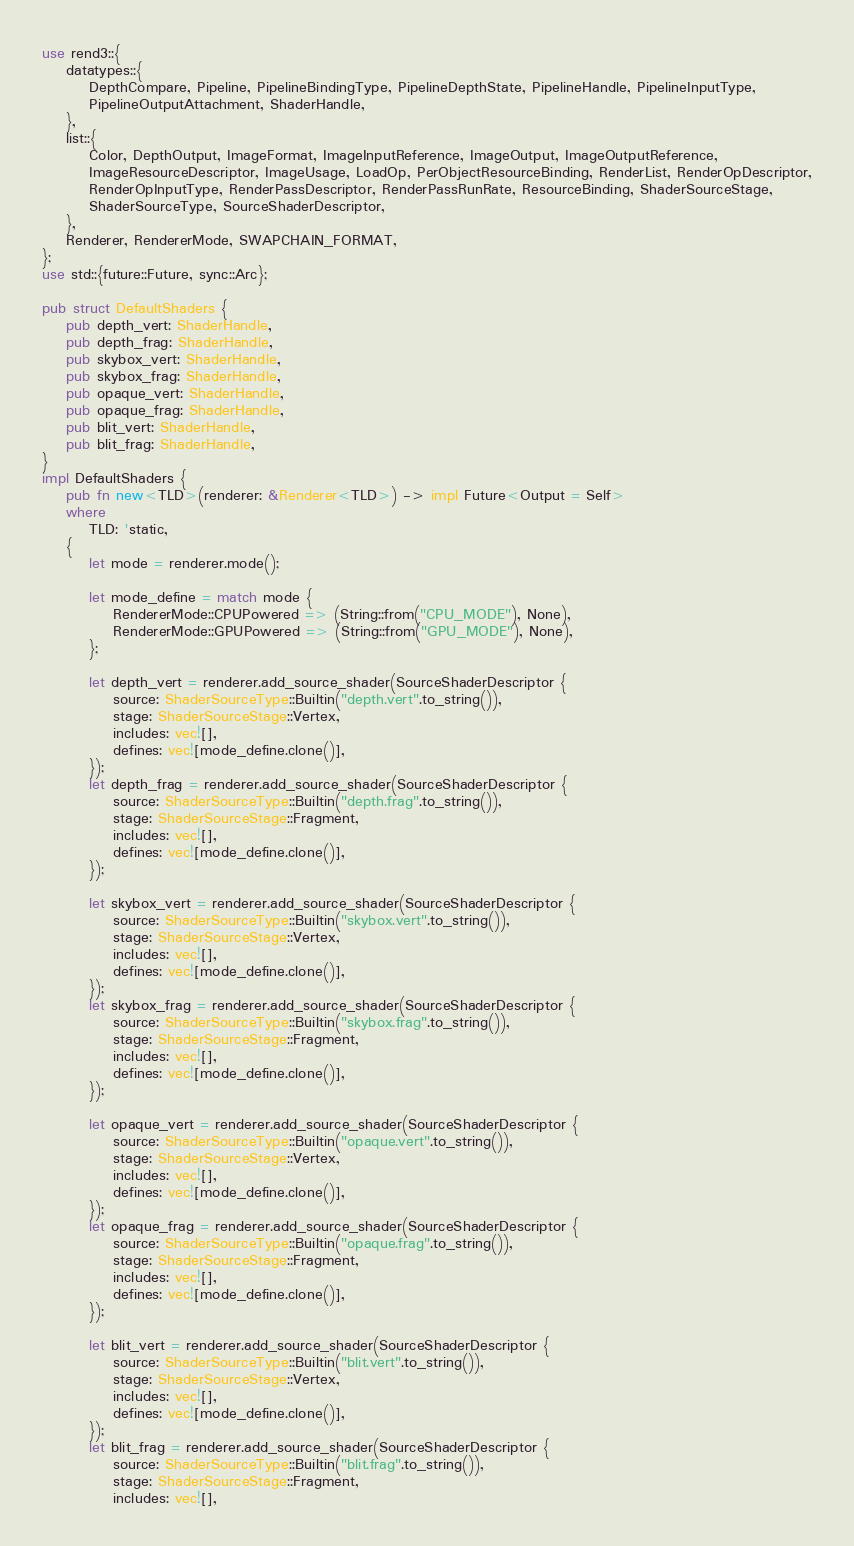<code> <loc_0><loc_0><loc_500><loc_500><_Rust_>use rend3::{
    datatypes::{
        DepthCompare, Pipeline, PipelineBindingType, PipelineDepthState, PipelineHandle, PipelineInputType,
        PipelineOutputAttachment, ShaderHandle,
    },
    list::{
        Color, DepthOutput, ImageFormat, ImageInputReference, ImageOutput, ImageOutputReference,
        ImageResourceDescriptor, ImageUsage, LoadOp, PerObjectResourceBinding, RenderList, RenderOpDescriptor,
        RenderOpInputType, RenderPassDescriptor, RenderPassRunRate, ResourceBinding, ShaderSourceStage,
        ShaderSourceType, SourceShaderDescriptor,
    },
    Renderer, RendererMode, SWAPCHAIN_FORMAT,
};
use std::{future::Future, sync::Arc};

pub struct DefaultShaders {
    pub depth_vert: ShaderHandle,
    pub depth_frag: ShaderHandle,
    pub skybox_vert: ShaderHandle,
    pub skybox_frag: ShaderHandle,
    pub opaque_vert: ShaderHandle,
    pub opaque_frag: ShaderHandle,
    pub blit_vert: ShaderHandle,
    pub blit_frag: ShaderHandle,
}
impl DefaultShaders {
    pub fn new<TLD>(renderer: &Renderer<TLD>) -> impl Future<Output = Self>
    where
        TLD: 'static,
    {
        let mode = renderer.mode();

        let mode_define = match mode {
            RendererMode::CPUPowered => (String::from("CPU_MODE"), None),
            RendererMode::GPUPowered => (String::from("GPU_MODE"), None),
        };

        let depth_vert = renderer.add_source_shader(SourceShaderDescriptor {
            source: ShaderSourceType::Builtin("depth.vert".to_string()),
            stage: ShaderSourceStage::Vertex,
            includes: vec![],
            defines: vec![mode_define.clone()],
        });
        let depth_frag = renderer.add_source_shader(SourceShaderDescriptor {
            source: ShaderSourceType::Builtin("depth.frag".to_string()),
            stage: ShaderSourceStage::Fragment,
            includes: vec![],
            defines: vec![mode_define.clone()],
        });

        let skybox_vert = renderer.add_source_shader(SourceShaderDescriptor {
            source: ShaderSourceType::Builtin("skybox.vert".to_string()),
            stage: ShaderSourceStage::Vertex,
            includes: vec![],
            defines: vec![mode_define.clone()],
        });
        let skybox_frag = renderer.add_source_shader(SourceShaderDescriptor {
            source: ShaderSourceType::Builtin("skybox.frag".to_string()),
            stage: ShaderSourceStage::Fragment,
            includes: vec![],
            defines: vec![mode_define.clone()],
        });

        let opaque_vert = renderer.add_source_shader(SourceShaderDescriptor {
            source: ShaderSourceType::Builtin("opaque.vert".to_string()),
            stage: ShaderSourceStage::Vertex,
            includes: vec![],
            defines: vec![mode_define.clone()],
        });
        let opaque_frag = renderer.add_source_shader(SourceShaderDescriptor {
            source: ShaderSourceType::Builtin("opaque.frag".to_string()),
            stage: ShaderSourceStage::Fragment,
            includes: vec![],
            defines: vec![mode_define.clone()],
        });

        let blit_vert = renderer.add_source_shader(SourceShaderDescriptor {
            source: ShaderSourceType::Builtin("blit.vert".to_string()),
            stage: ShaderSourceStage::Vertex,
            includes: vec![],
            defines: vec![mode_define.clone()],
        });
        let blit_frag = renderer.add_source_shader(SourceShaderDescriptor {
            source: ShaderSourceType::Builtin("blit.frag".to_string()),
            stage: ShaderSourceStage::Fragment,
            includes: vec![],</code> 